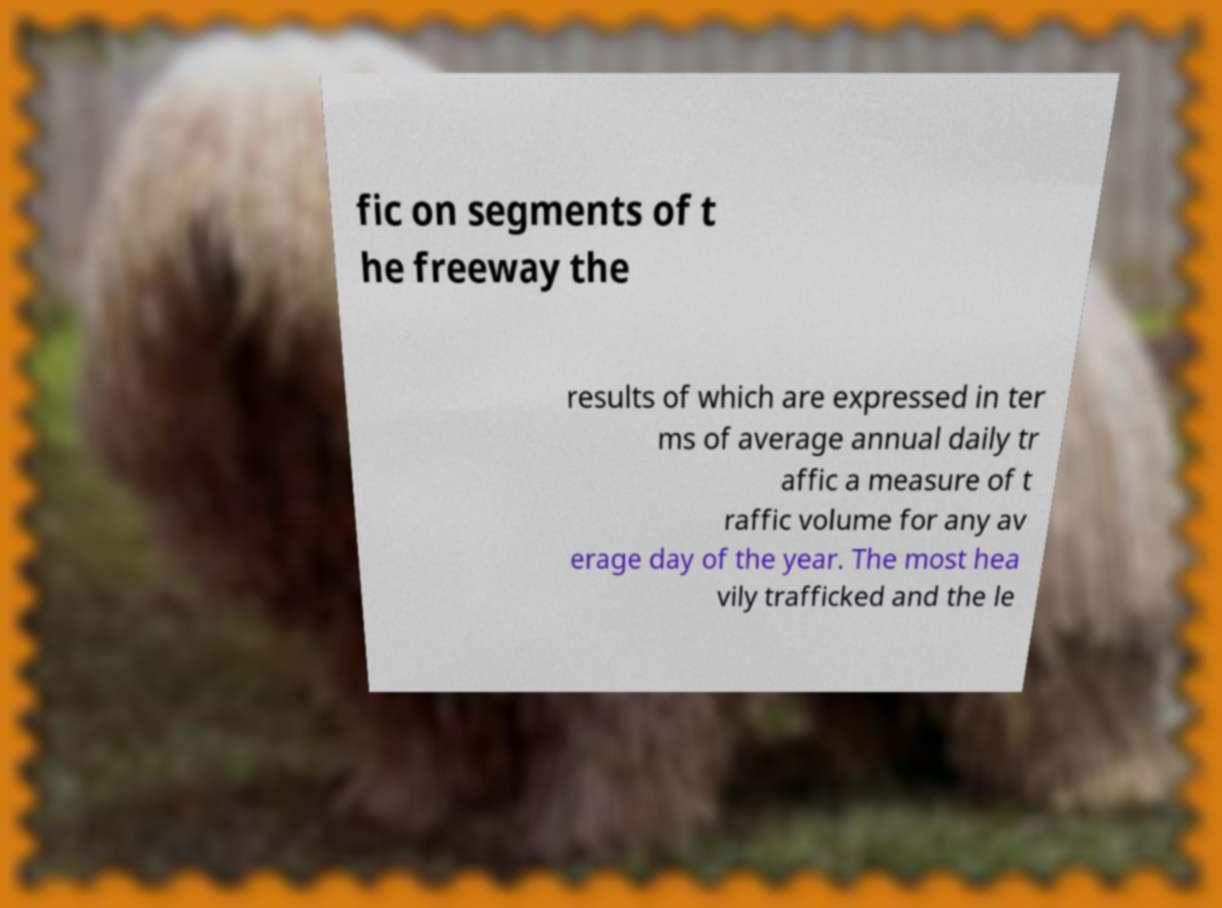What messages or text are displayed in this image? I need them in a readable, typed format. fic on segments of t he freeway the results of which are expressed in ter ms of average annual daily tr affic a measure of t raffic volume for any av erage day of the year. The most hea vily trafficked and the le 